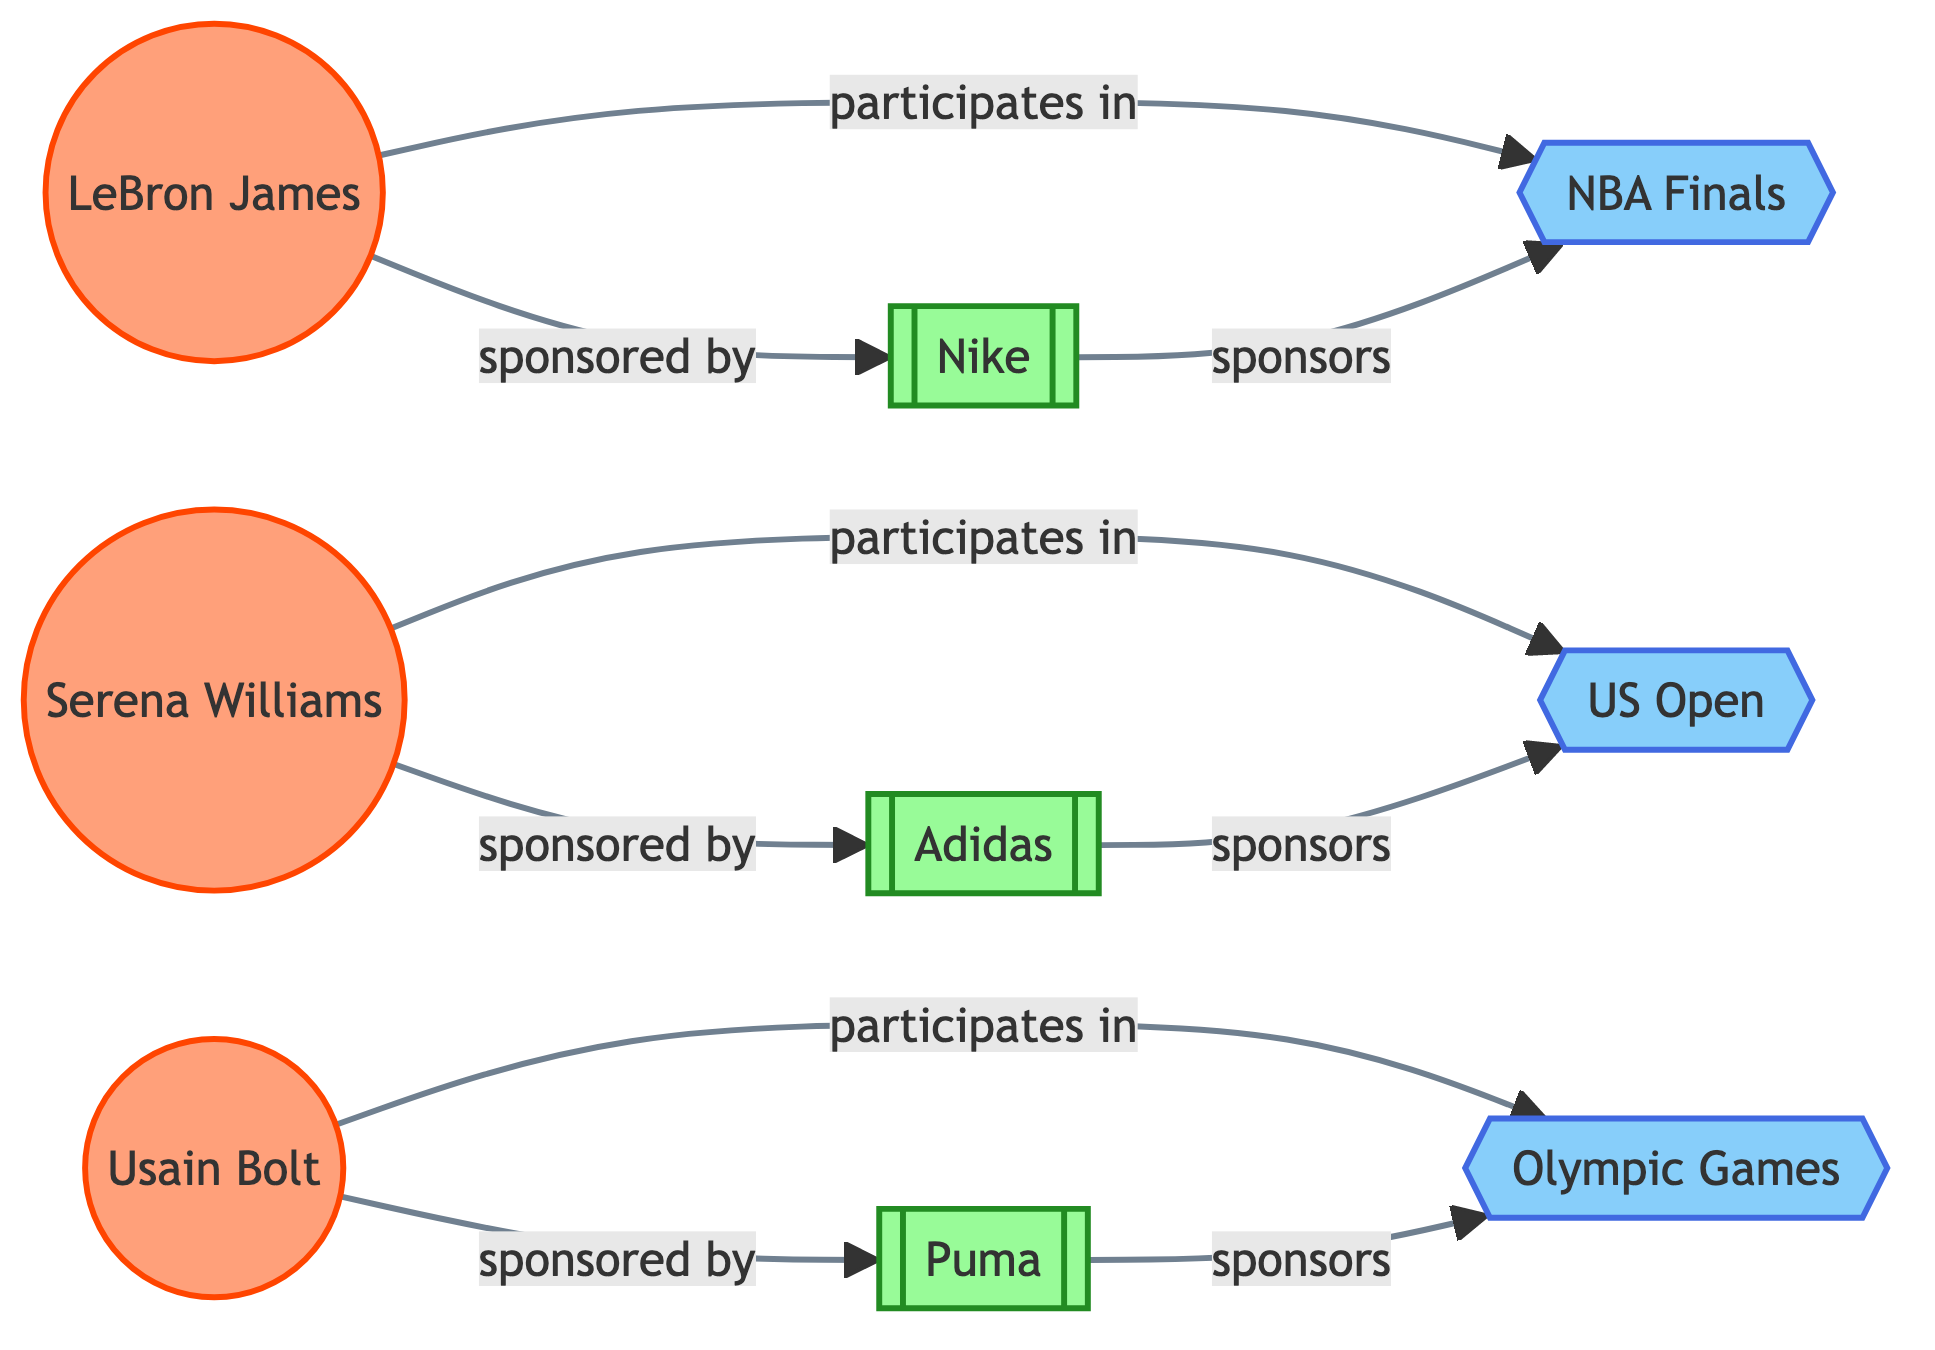What athletes are sponsored by Nike? The diagram shows a link from LeBron James to Nike with the relationship "sponsored by". Hence, LeBron James is the athlete sponsored by Nike.
Answer: LeBron James Which brand sponsors the US Open? According to the diagram, there is a link from Adidas to the US Open with the relationship "sponsors". This indicates that Adidas is the brand sponsoring this event.
Answer: Adidas How many athletes are in the diagram? The diagram includes three nodes labeled as athletes: LeBron James, Serena Williams, and Usain Bolt. Counting these nodes gives a total of three athletes.
Answer: 3 What event does Usain Bolt participate in? The diagram shows a link from Usain Bolt to the Olympic Games with the relationship "participates in". This indicates that Usain Bolt participates in the Olympic Games.
Answer: Olympic Games Which athlete is sponsored by Puma? The diagram includes a link from Usain Bolt to Puma with the relationship "sponsored by". Therefore, Usain Bolt is the athlete sponsored by Puma.
Answer: Usain Bolt What is the total number of sponsorship relationships depicted in the diagram? The diagram indicates three sponsorship relationships: LeBron James to Nike, Serena Williams to Adidas, and Usain Bolt to Puma. Counting these relationships gives a total of three sponsorship links.
Answer: 3 Which brand does LeBron James participate with? The diagram shows that LeBron James participates in the NBA Finals, and Nike is the brand that sponsors this event. Thus, the brand associated with LeBron James' participation is Nike.
Answer: Nike Which two events have sponsorship relationships in the diagram? The diagram shows two events with distinct sponsorship relationships: the NBA Finals sponsored by Nike and the US Open sponsored by Adidas. Thus, NBA Finals and US Open are the two events with sponsorships.
Answer: NBA Finals and US Open 